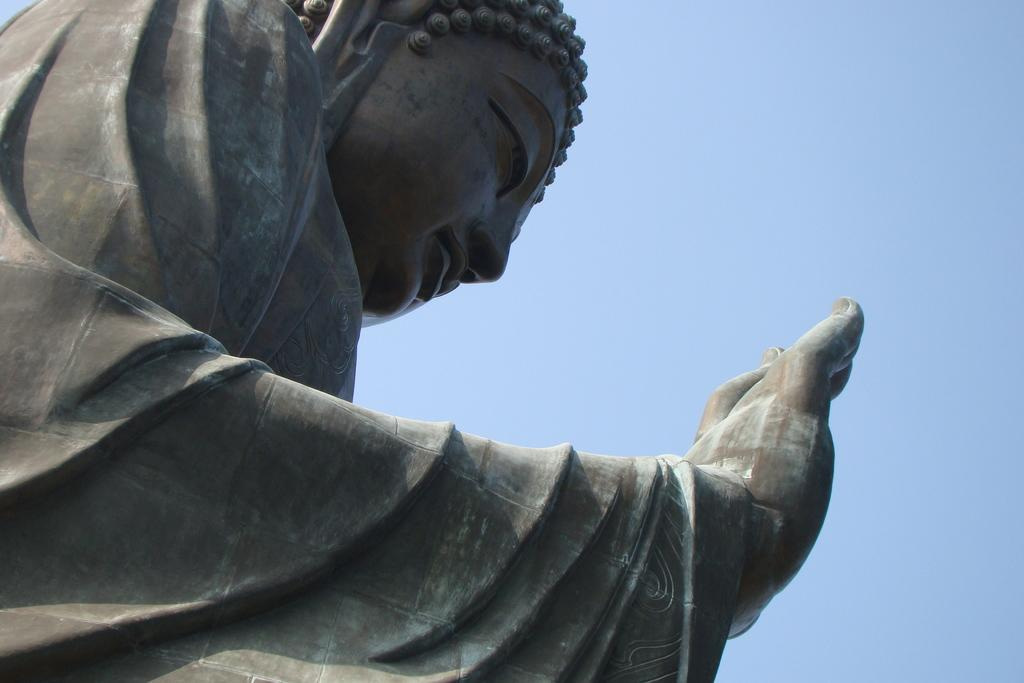What is located on the left side of the image? There is a statue on the left side of the image. What can be seen in the background of the image? The sky is visible in the background of the image. What type of bean is hanging from the statue in the image? There is no bean present in the image, and the statue is not depicted as having any beans hanging from it. 